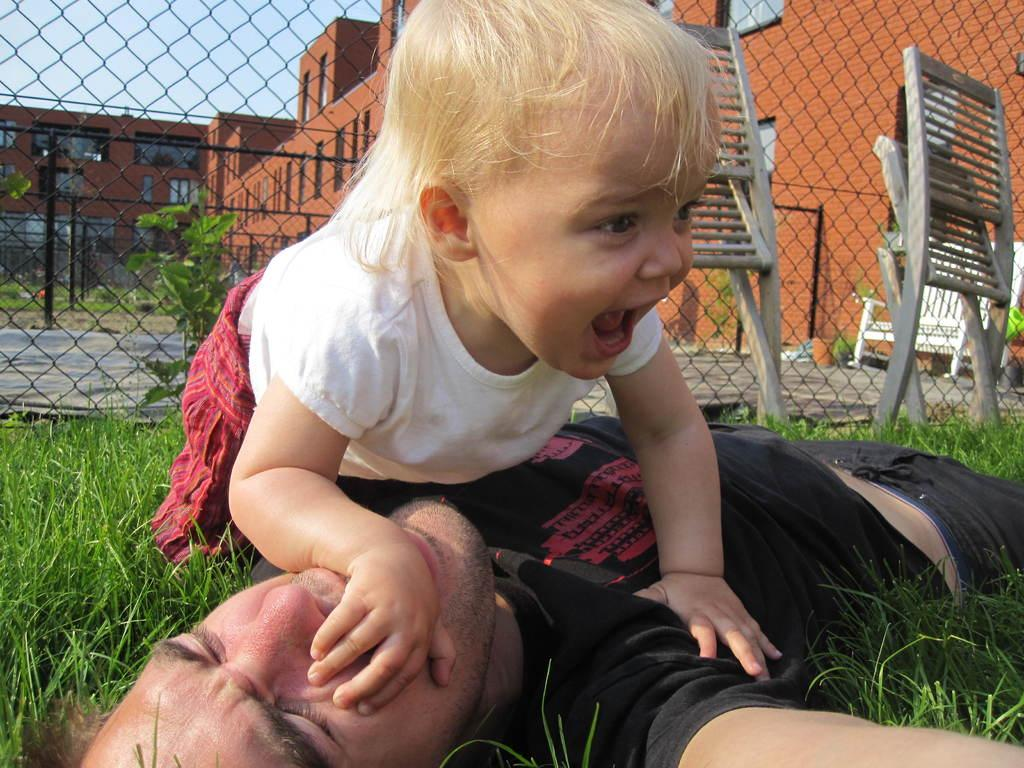What is the man in the image doing? The man is laying down in the image. Where is the man located? The man is on a grassland. What is happening above the man? There is a girl above the man. What can be seen in the background of the image? There are two chairs, fencing, buildings, and the sky visible in the background. What type of sign is the man holding in the image? There is no sign present in the image; the man is simply laying down on the grassland. 